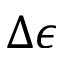Convert formula to latex. <formula><loc_0><loc_0><loc_500><loc_500>\Delta \epsilon</formula> 